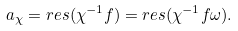Convert formula to latex. <formula><loc_0><loc_0><loc_500><loc_500>a _ { \chi } = r e s ( \chi ^ { - 1 } f ) = r e s ( \chi ^ { - 1 } f \omega ) .</formula> 